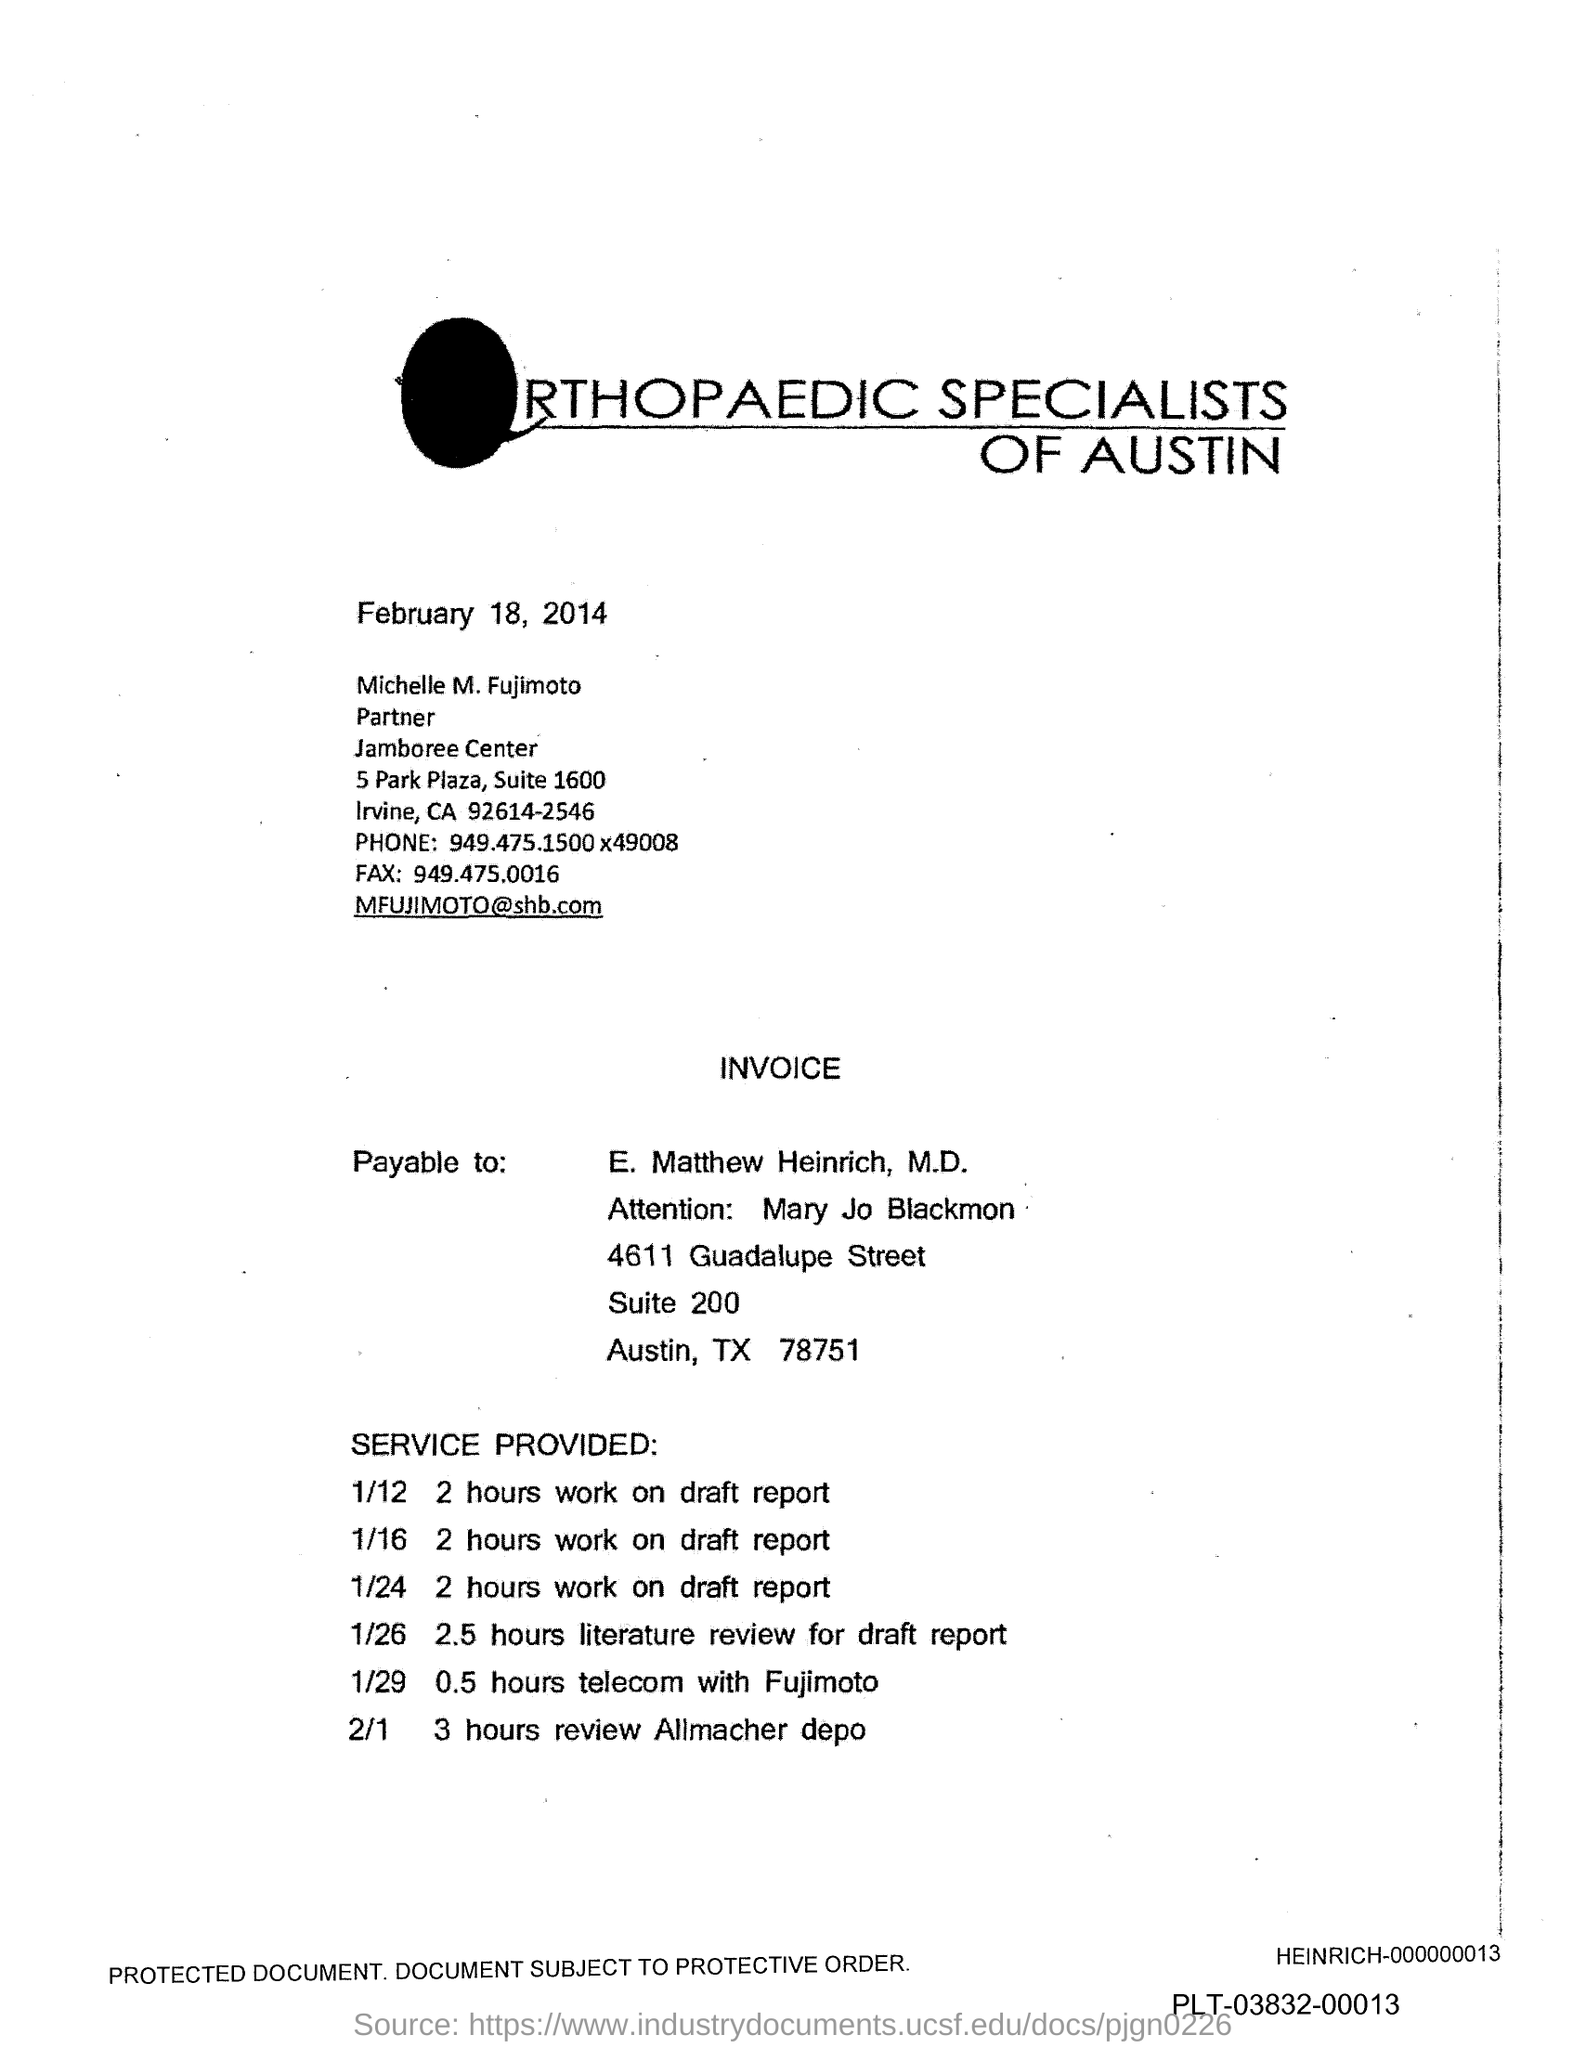What is the Fax number?
Offer a very short reply. 949.475.0016. 